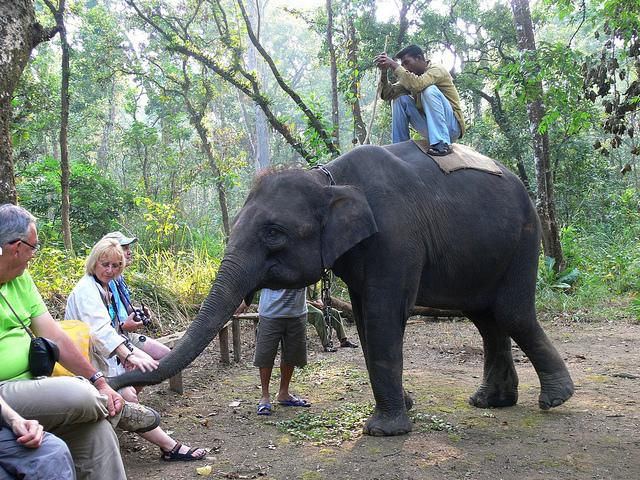What other animal is this animal traditionally afraid of?

Choices:
A) tigers
B) rhinos
C) cats
D) mice mice 